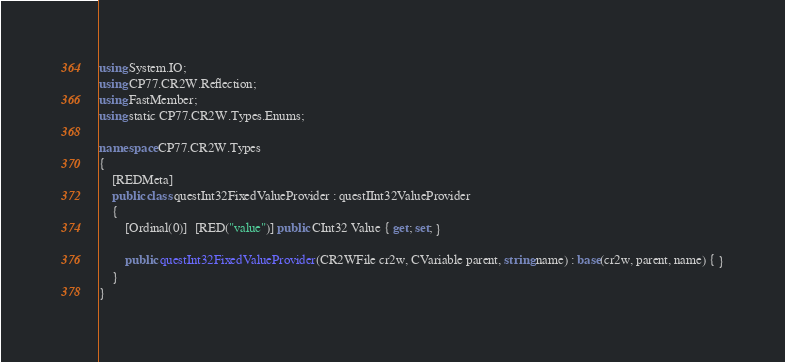Convert code to text. <code><loc_0><loc_0><loc_500><loc_500><_C#_>using System.IO;
using CP77.CR2W.Reflection;
using FastMember;
using static CP77.CR2W.Types.Enums;

namespace CP77.CR2W.Types
{
	[REDMeta]
	public class questInt32FixedValueProvider : questIInt32ValueProvider
	{
		[Ordinal(0)]  [RED("value")] public CInt32 Value { get; set; }

		public questInt32FixedValueProvider(CR2WFile cr2w, CVariable parent, string name) : base(cr2w, parent, name) { }
	}
}
</code> 